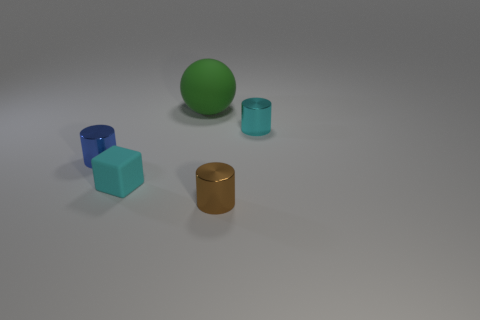There is a cyan object that is the same size as the block; what shape is it?
Your answer should be compact. Cylinder. What is the material of the thing that is the same color as the cube?
Your answer should be compact. Metal. Are there more tiny brown cylinders than small yellow matte cylinders?
Your response must be concise. Yes. The brown shiny thing that is the same shape as the cyan metal thing is what size?
Make the answer very short. Small. Is the material of the blue object the same as the tiny cyan object that is to the left of the large green object?
Your answer should be compact. No. What number of things are cyan spheres or large green rubber spheres?
Keep it short and to the point. 1. There is a cylinder to the left of the big green matte sphere; does it have the same size as the cylinder that is in front of the tiny cyan cube?
Offer a very short reply. Yes. What number of spheres are small cyan objects or small blue objects?
Provide a succinct answer. 0. Is there a large blue metal sphere?
Your answer should be very brief. No. Are there any other things that have the same shape as the small blue thing?
Keep it short and to the point. Yes. 